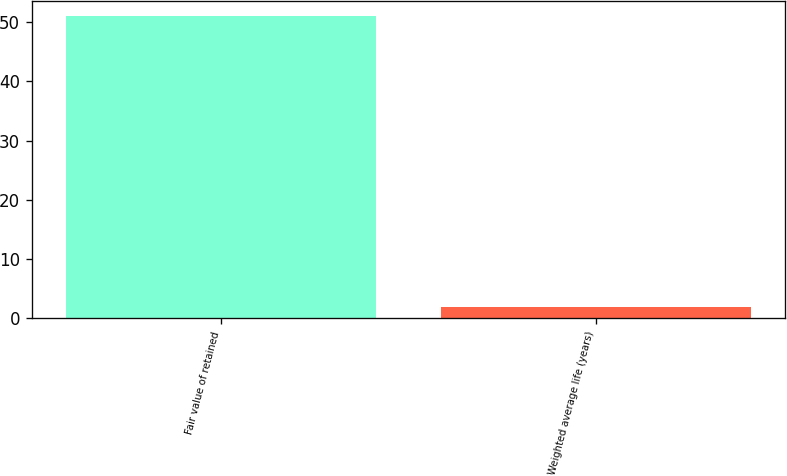Convert chart. <chart><loc_0><loc_0><loc_500><loc_500><bar_chart><fcel>Fair value of retained<fcel>Weighted average life (years)<nl><fcel>51<fcel>2<nl></chart> 